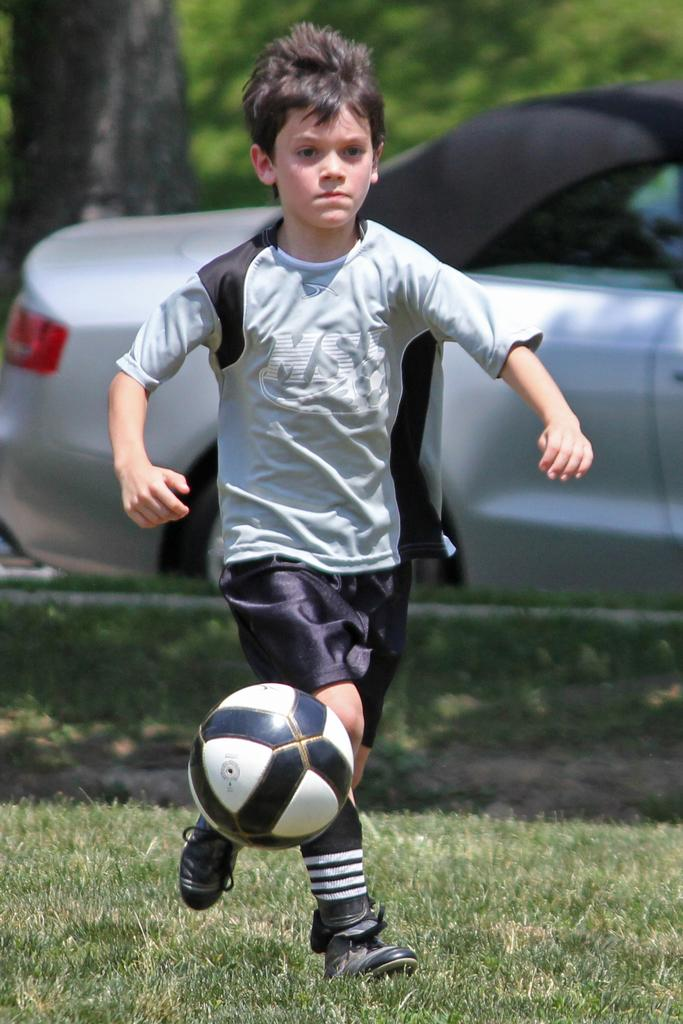Who is the main subject in the image? There is a boy in the image. What is the boy doing in the image? The boy is playing with a ball. Where is the ball located in the image? The ball is on grass. What can be seen behind the boy in the image? There is a car behind the boy. How many icicles are hanging from the boy's neck in the image? There are no icicles present in the image, and the boy's neck is not mentioned. What type of lift is visible in the image? There is no lift present in the image. 